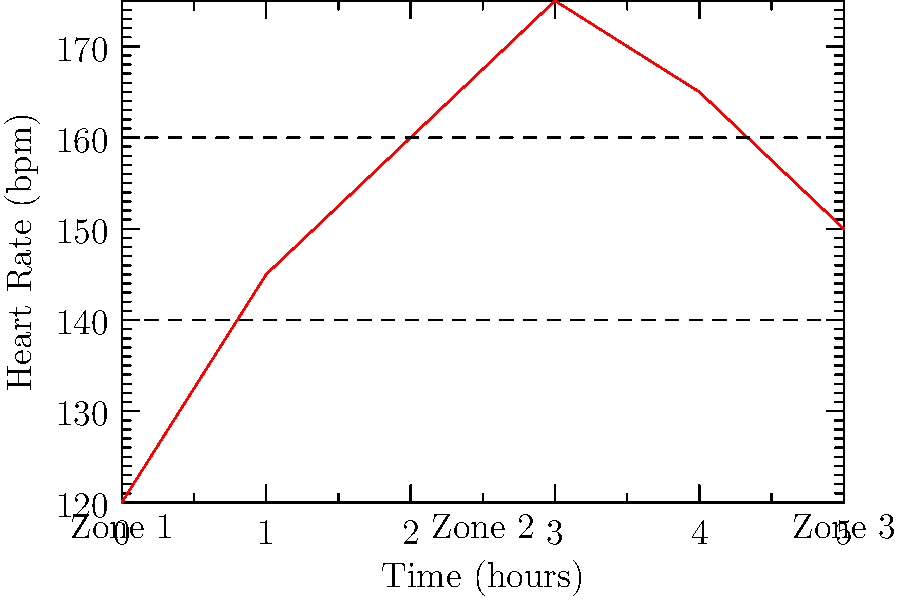During a 5-hour race walking event, your heart rate was monitored and plotted on the graph above. In which heart rate zone did you spend the most time during the event? To determine the heart rate zone where the most time was spent, we need to analyze the graph:

1. The graph shows three heart rate zones:
   - Zone 1: Below 140 bpm
   - Zone 2: Between 140 and 160 bpm
   - Zone 3: Above 160 bpm

2. Let's break down the time spent in each zone:
   - Hour 0-1: Mostly in Zone 1
   - Hour 1-2: Mostly in Zone 2
   - Hour 2-3: Transition from Zone 2 to Zone 3
   - Hour 3-4: Mostly in Zone 3
   - Hour 4-5: Transition from Zone 3 to Zone 2

3. Approximate time spent in each zone:
   - Zone 1: ~1 hour
   - Zone 2: ~2 hours
   - Zone 3: ~2 hours

4. Both Zone 2 and Zone 3 have the most time spent, but Zone 2 appears slightly longer when considering the transitions.

Therefore, Zone 2 is the heart rate zone where the most time was spent during the event.
Answer: Zone 2 